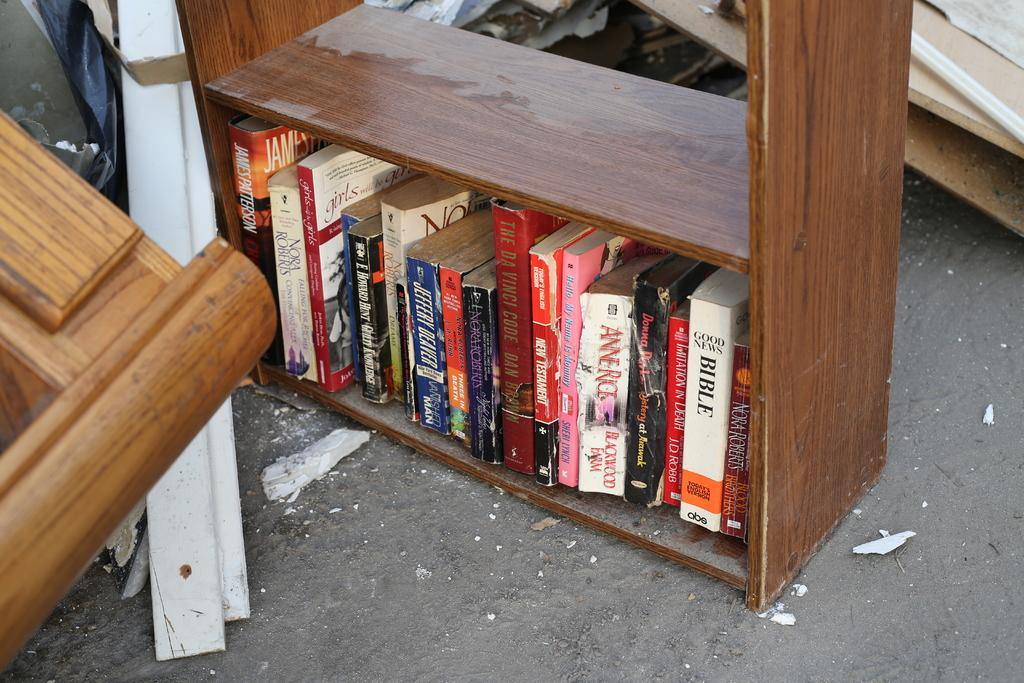What type of items can be seen on the shelf in the image? There are books in a shelf in the image. What other objects are present in the image besides the books? There are other objects in the image, but their specific details are not mentioned in the provided facts. What is located at the bottom of the image? There is a road at the bottom of the image. How many spiders are crawling on the canvas in the image? There is no canvas or spiders present in the image. 